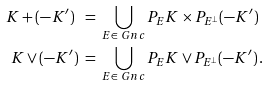Convert formula to latex. <formula><loc_0><loc_0><loc_500><loc_500>K + ( - K ^ { \prime } ) \ & = \ \bigcup _ { E \in \ G n c } P _ { E } K \times P _ { E ^ { \perp } } ( - K ^ { \prime } ) \\ K \vee ( - K ^ { \prime } ) \ & = \ \bigcup _ { E \in \ G n c } P _ { E } K \vee P _ { E ^ { \perp } } ( - K ^ { \prime } ) \, .</formula> 